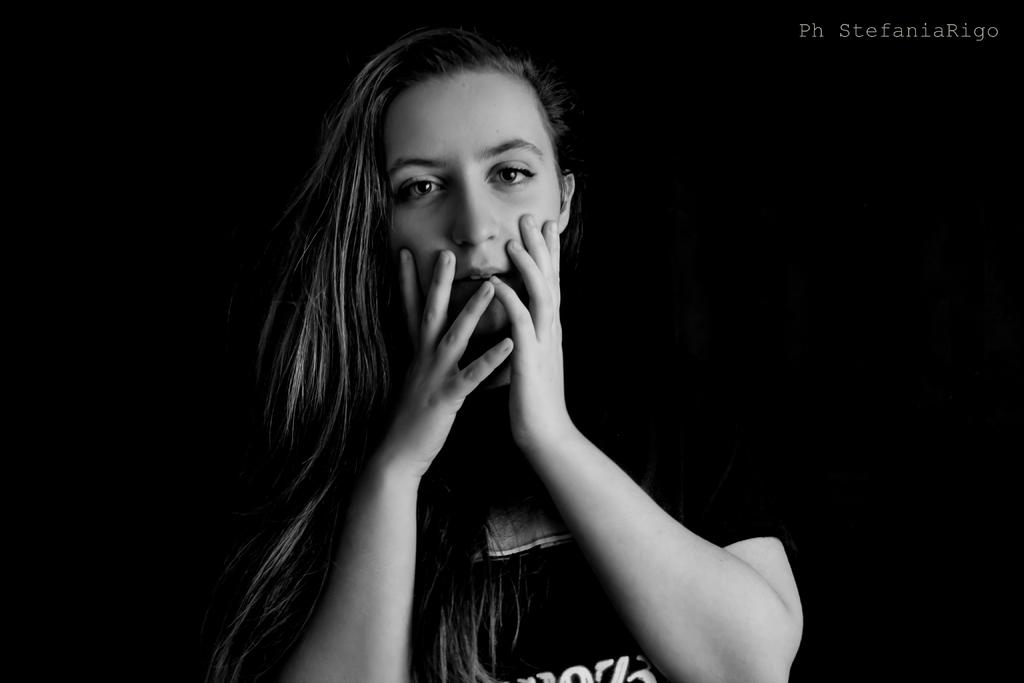Who is present in the image? There is a woman in the image. What can be seen on the woman's dress? There is writing on the woman's dress. Is there any additional text or symbol in the image? Yes, there is a watermark in the image. What is the color scheme of the image? The image is black and white in color. What type of moon can be seen in the image? There is no moon present in the image. Can you describe the office setting in the image? There is no office setting in the image; it features a woman with writing on her dress and a watermark. 